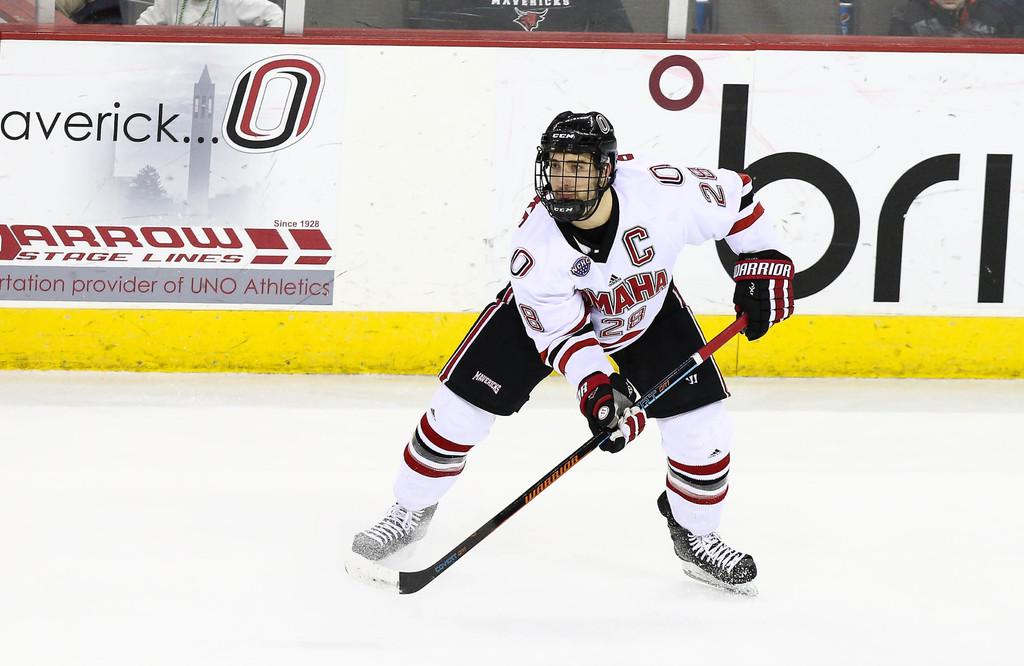<image>
Summarize the visual content of the image. An ice hockey player for Omaha is ready for play on the ice. 